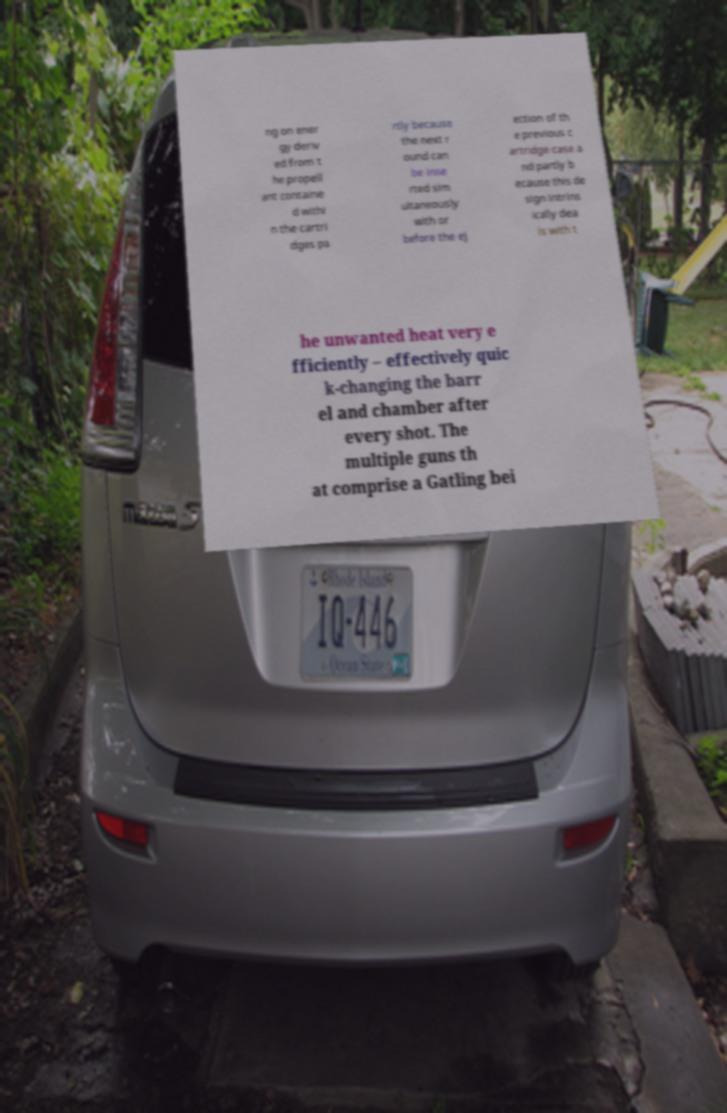Could you assist in decoding the text presented in this image and type it out clearly? ng on ener gy deriv ed from t he propell ant containe d withi n the cartri dges pa rtly because the next r ound can be inse rted sim ultaneously with or before the ej ection of th e previous c artridge case a nd partly b ecause this de sign intrins ically dea ls with t he unwanted heat very e fficiently – effectively quic k-changing the barr el and chamber after every shot. The multiple guns th at comprise a Gatling bei 